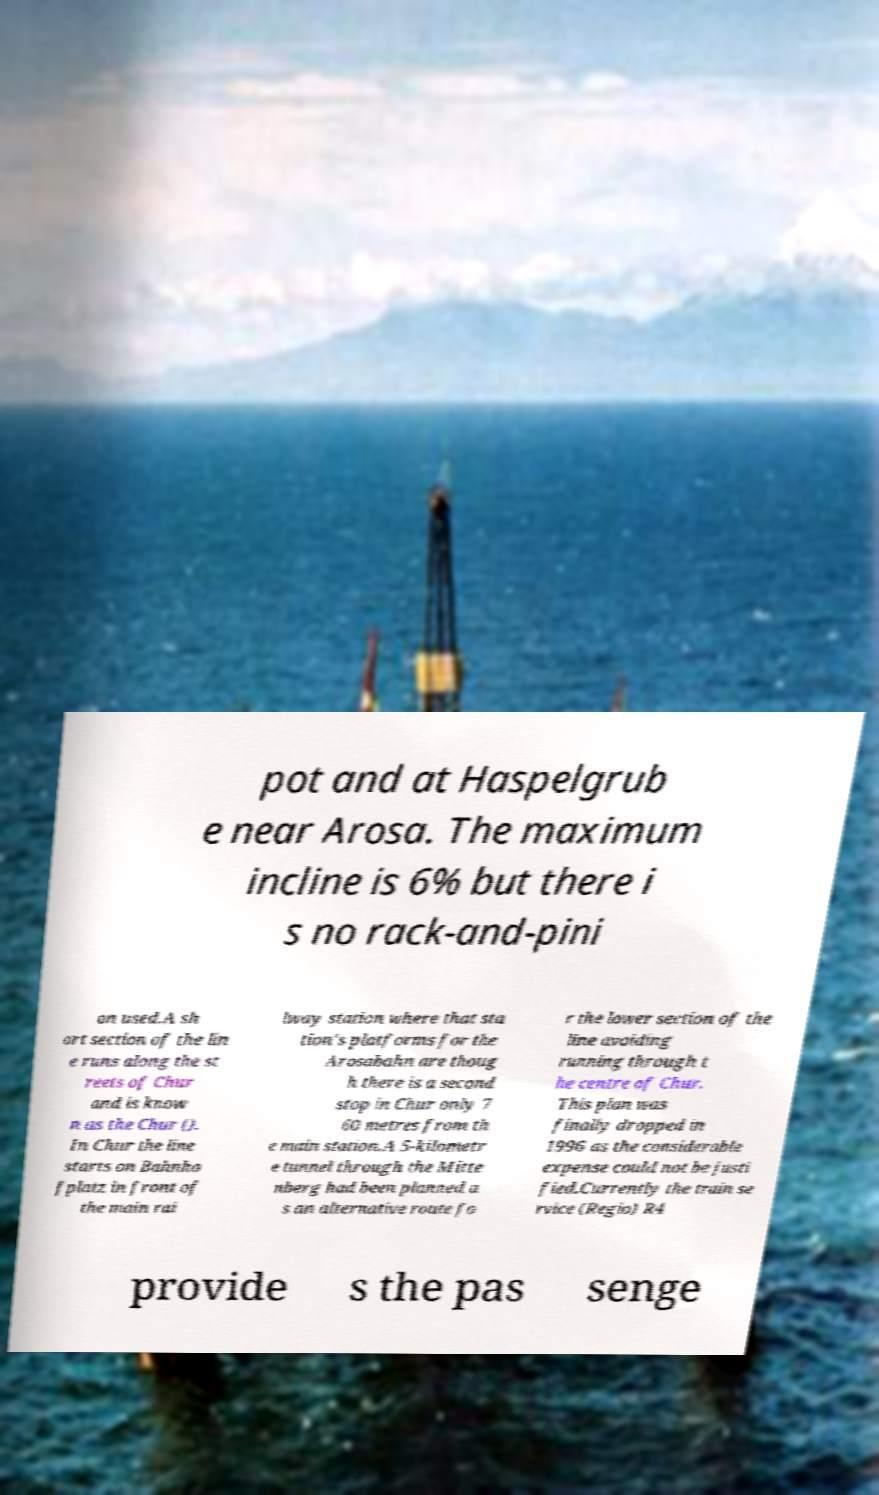Could you extract and type out the text from this image? pot and at Haspelgrub e near Arosa. The maximum incline is 6% but there i s no rack-and-pini on used.A sh ort section of the lin e runs along the st reets of Chur and is know n as the Chur (). In Chur the line starts on Bahnho fplatz in front of the main rai lway station where that sta tion's platforms for the Arosabahn are thoug h there is a second stop in Chur only 7 60 metres from th e main station.A 5-kilometr e tunnel through the Mitte nberg had been planned a s an alternative route fo r the lower section of the line avoiding running through t he centre of Chur. This plan was finally dropped in 1996 as the considerable expense could not be justi fied.Currently the train se rvice (Regio) R4 provide s the pas senge 